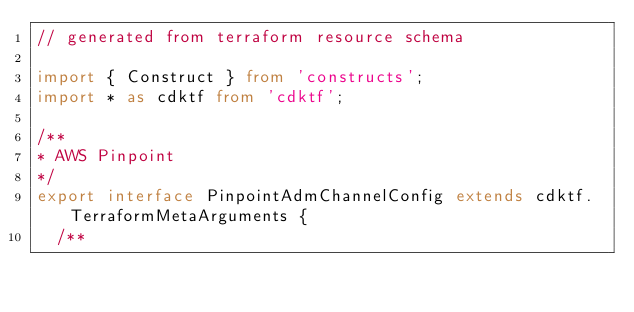<code> <loc_0><loc_0><loc_500><loc_500><_TypeScript_>// generated from terraform resource schema

import { Construct } from 'constructs';
import * as cdktf from 'cdktf';

/**
* AWS Pinpoint
*/
export interface PinpointAdmChannelConfig extends cdktf.TerraformMetaArguments {
  /**</code> 